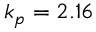<formula> <loc_0><loc_0><loc_500><loc_500>k _ { p } = 2 . 1 6</formula> 